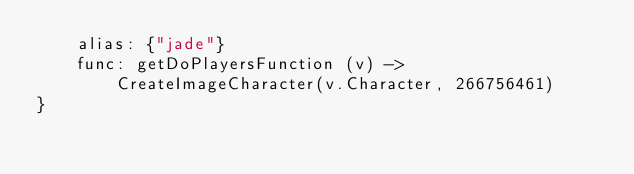<code> <loc_0><loc_0><loc_500><loc_500><_MoonScript_>	alias: {"jade"}
	func: getDoPlayersFunction (v) ->
		CreateImageCharacter(v.Character, 266756461)
}</code> 